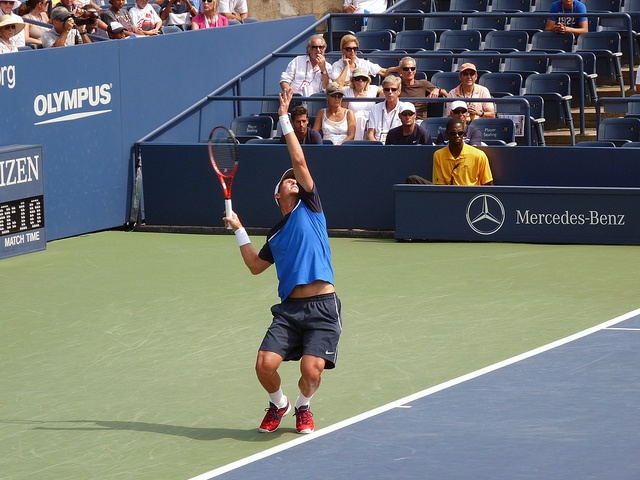Describe the objects in this image and their specific colors. I can see people in gray, black, maroon, and lightblue tones, people in gray, olive, black, orange, and khaki tones, people in gray, lavender, darkgray, and brown tones, people in gray, lightgray, brown, maroon, and darkgray tones, and people in gray, white, maroon, black, and lightpink tones in this image. 